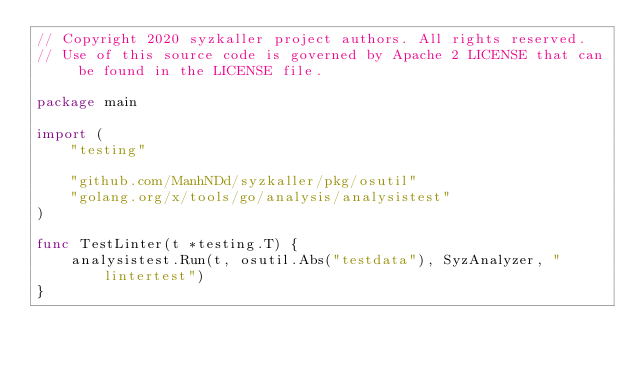<code> <loc_0><loc_0><loc_500><loc_500><_Go_>// Copyright 2020 syzkaller project authors. All rights reserved.
// Use of this source code is governed by Apache 2 LICENSE that can be found in the LICENSE file.

package main

import (
	"testing"

	"github.com/ManhNDd/syzkaller/pkg/osutil"
	"golang.org/x/tools/go/analysis/analysistest"
)

func TestLinter(t *testing.T) {
	analysistest.Run(t, osutil.Abs("testdata"), SyzAnalyzer, "lintertest")
}
</code> 